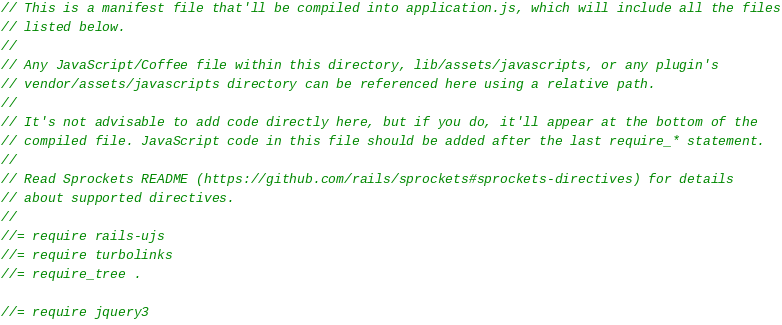<code> <loc_0><loc_0><loc_500><loc_500><_JavaScript_>// This is a manifest file that'll be compiled into application.js, which will include all the files
// listed below.
//
// Any JavaScript/Coffee file within this directory, lib/assets/javascripts, or any plugin's
// vendor/assets/javascripts directory can be referenced here using a relative path.
//
// It's not advisable to add code directly here, but if you do, it'll appear at the bottom of the
// compiled file. JavaScript code in this file should be added after the last require_* statement.
//
// Read Sprockets README (https://github.com/rails/sprockets#sprockets-directives) for details
// about supported directives.
//
//= require rails-ujs
//= require turbolinks
//= require_tree .

//= require jquery3
</code> 